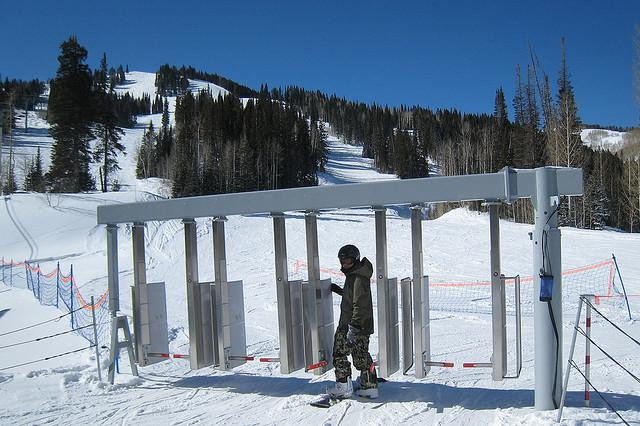What is the skier passing through? Please explain your reasoning. gate. There is a metal gate near the skiier. 